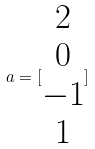Convert formula to latex. <formula><loc_0><loc_0><loc_500><loc_500>a = [ \begin{matrix} 2 \\ 0 \\ - 1 \\ 1 \end{matrix} ]</formula> 